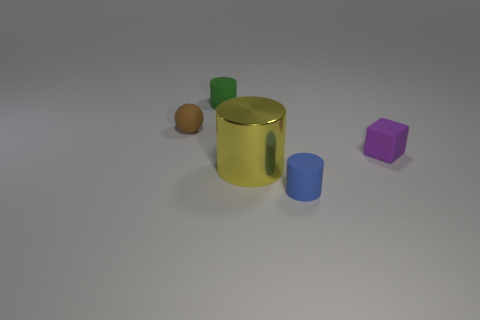Add 4 small brown metallic cylinders. How many objects exist? 9 Subtract all cylinders. How many objects are left? 2 Add 3 small green things. How many small green things are left? 4 Add 3 big blue cylinders. How many big blue cylinders exist? 3 Subtract 0 purple spheres. How many objects are left? 5 Subtract all big cyan matte things. Subtract all blue cylinders. How many objects are left? 4 